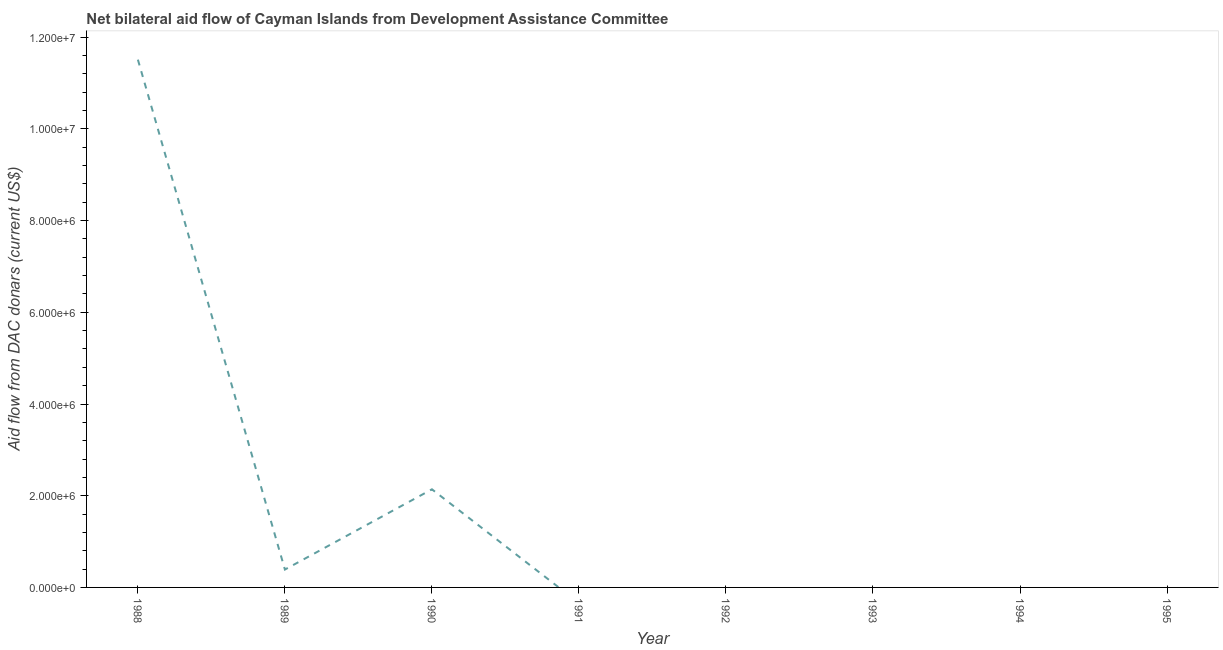Across all years, what is the maximum net bilateral aid flows from dac donors?
Offer a terse response. 1.15e+07. What is the sum of the net bilateral aid flows from dac donors?
Make the answer very short. 1.40e+07. What is the difference between the net bilateral aid flows from dac donors in 1989 and 1990?
Make the answer very short. -1.75e+06. What is the average net bilateral aid flows from dac donors per year?
Give a very brief answer. 1.76e+06. What is the median net bilateral aid flows from dac donors?
Your answer should be very brief. 0. In how many years, is the net bilateral aid flows from dac donors greater than 4800000 US$?
Make the answer very short. 1. What is the difference between the highest and the second highest net bilateral aid flows from dac donors?
Provide a short and direct response. 9.37e+06. What is the difference between the highest and the lowest net bilateral aid flows from dac donors?
Make the answer very short. 1.15e+07. In how many years, is the net bilateral aid flows from dac donors greater than the average net bilateral aid flows from dac donors taken over all years?
Keep it short and to the point. 2. Does the net bilateral aid flows from dac donors monotonically increase over the years?
Your answer should be compact. No. How many lines are there?
Keep it short and to the point. 1. How many years are there in the graph?
Make the answer very short. 8. Are the values on the major ticks of Y-axis written in scientific E-notation?
Your response must be concise. Yes. What is the title of the graph?
Keep it short and to the point. Net bilateral aid flow of Cayman Islands from Development Assistance Committee. What is the label or title of the Y-axis?
Your response must be concise. Aid flow from DAC donars (current US$). What is the Aid flow from DAC donars (current US$) of 1988?
Provide a succinct answer. 1.15e+07. What is the Aid flow from DAC donars (current US$) of 1989?
Keep it short and to the point. 3.90e+05. What is the Aid flow from DAC donars (current US$) of 1990?
Offer a terse response. 2.14e+06. What is the Aid flow from DAC donars (current US$) of 1991?
Your response must be concise. 0. What is the Aid flow from DAC donars (current US$) of 1992?
Give a very brief answer. 0. What is the difference between the Aid flow from DAC donars (current US$) in 1988 and 1989?
Ensure brevity in your answer.  1.11e+07. What is the difference between the Aid flow from DAC donars (current US$) in 1988 and 1990?
Give a very brief answer. 9.37e+06. What is the difference between the Aid flow from DAC donars (current US$) in 1989 and 1990?
Your answer should be compact. -1.75e+06. What is the ratio of the Aid flow from DAC donars (current US$) in 1988 to that in 1989?
Ensure brevity in your answer.  29.51. What is the ratio of the Aid flow from DAC donars (current US$) in 1988 to that in 1990?
Ensure brevity in your answer.  5.38. What is the ratio of the Aid flow from DAC donars (current US$) in 1989 to that in 1990?
Your answer should be very brief. 0.18. 